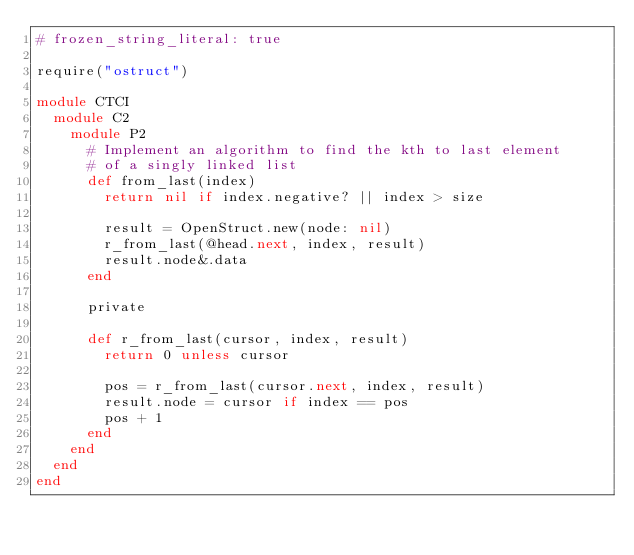Convert code to text. <code><loc_0><loc_0><loc_500><loc_500><_Ruby_># frozen_string_literal: true

require("ostruct")

module CTCI
  module C2
    module P2
      # Implement an algorithm to find the kth to last element
      # of a singly linked list
      def from_last(index)
        return nil if index.negative? || index > size

        result = OpenStruct.new(node: nil)
        r_from_last(@head.next, index, result)
        result.node&.data
      end

      private

      def r_from_last(cursor, index, result)
        return 0 unless cursor

        pos = r_from_last(cursor.next, index, result)
        result.node = cursor if index == pos
        pos + 1
      end
    end
  end
end
</code> 